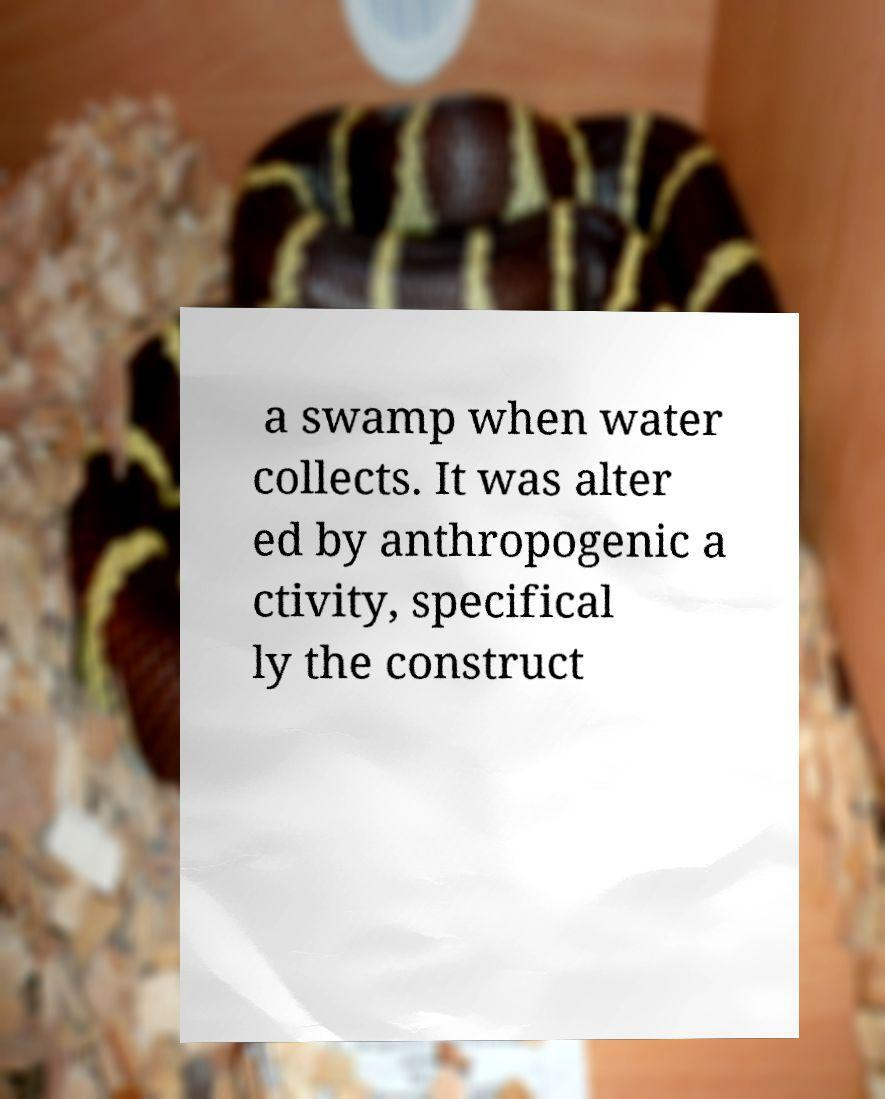For documentation purposes, I need the text within this image transcribed. Could you provide that? a swamp when water collects. It was alter ed by anthropogenic a ctivity, specifical ly the construct 